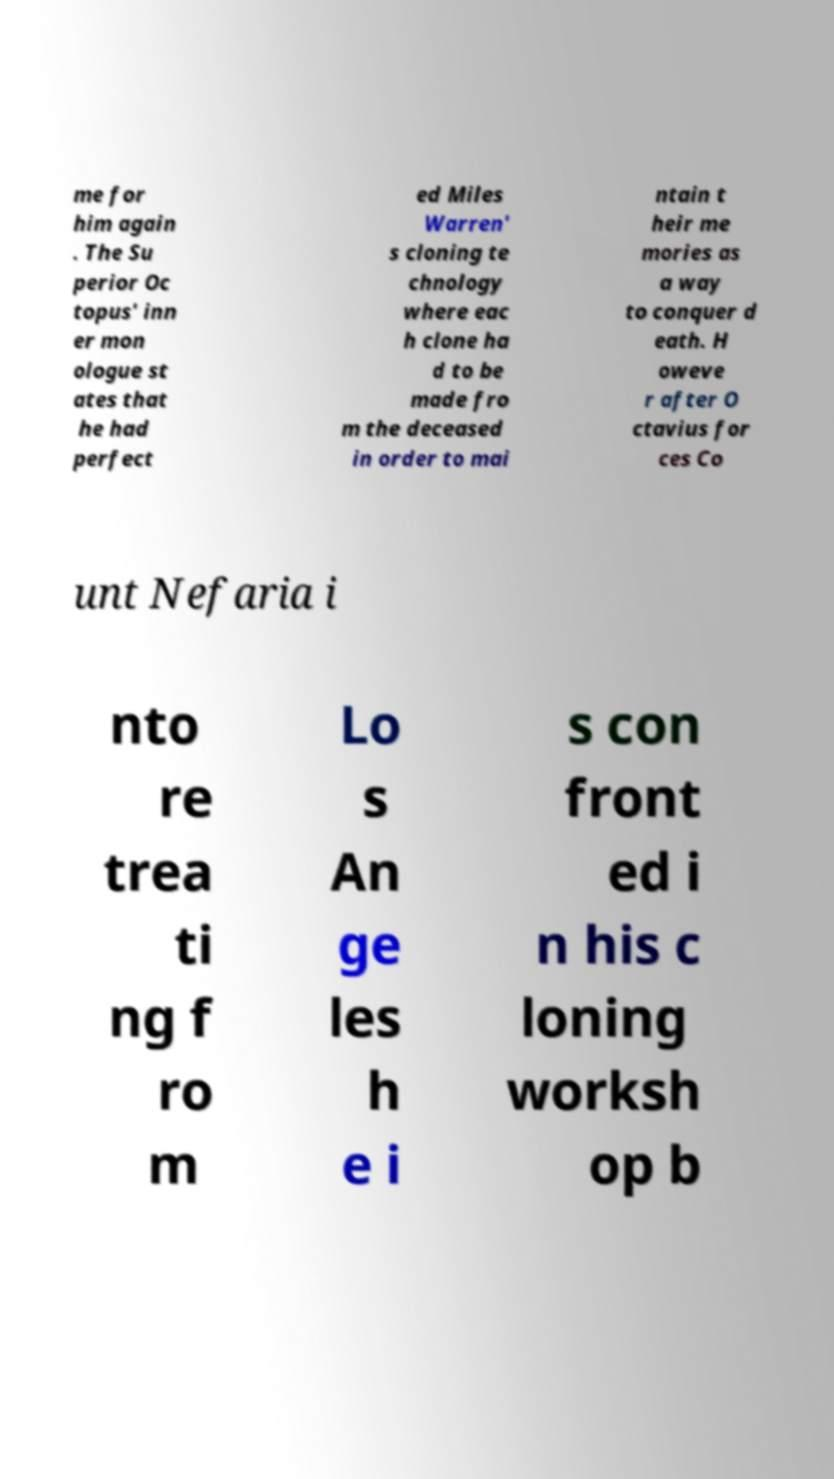Could you extract and type out the text from this image? me for him again . The Su perior Oc topus' inn er mon ologue st ates that he had perfect ed Miles Warren' s cloning te chnology where eac h clone ha d to be made fro m the deceased in order to mai ntain t heir me mories as a way to conquer d eath. H oweve r after O ctavius for ces Co unt Nefaria i nto re trea ti ng f ro m Lo s An ge les h e i s con front ed i n his c loning worksh op b 